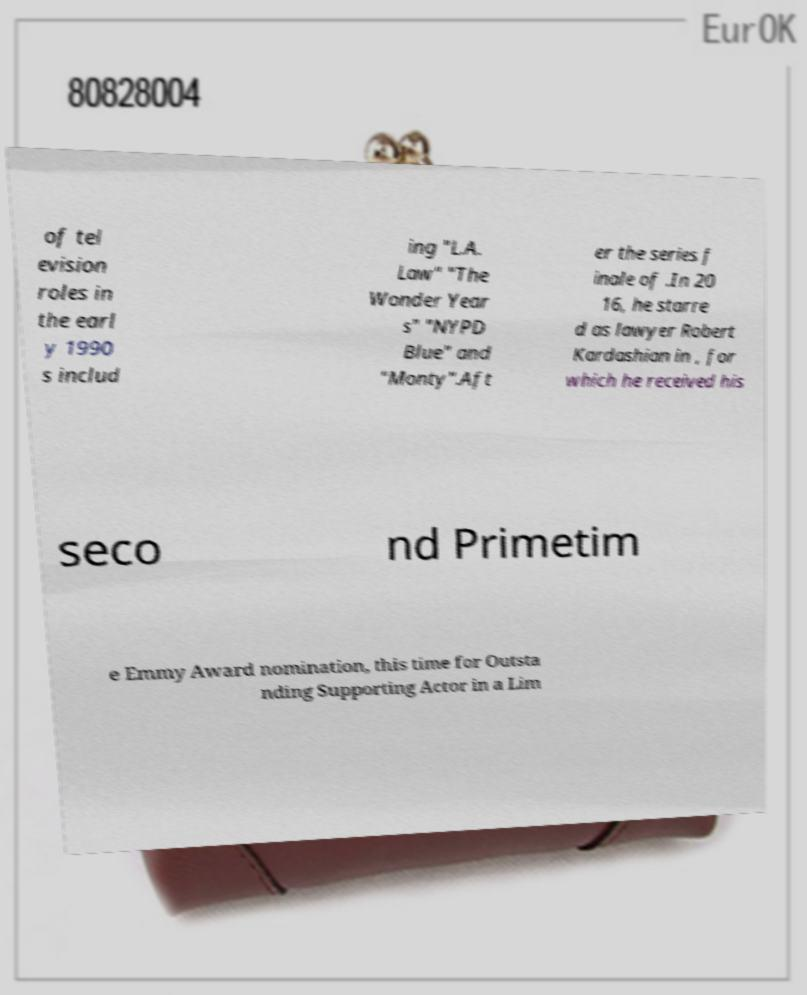For documentation purposes, I need the text within this image transcribed. Could you provide that? of tel evision roles in the earl y 1990 s includ ing "L.A. Law" "The Wonder Year s" "NYPD Blue" and "Monty".Aft er the series f inale of .In 20 16, he starre d as lawyer Robert Kardashian in , for which he received his seco nd Primetim e Emmy Award nomination, this time for Outsta nding Supporting Actor in a Lim 